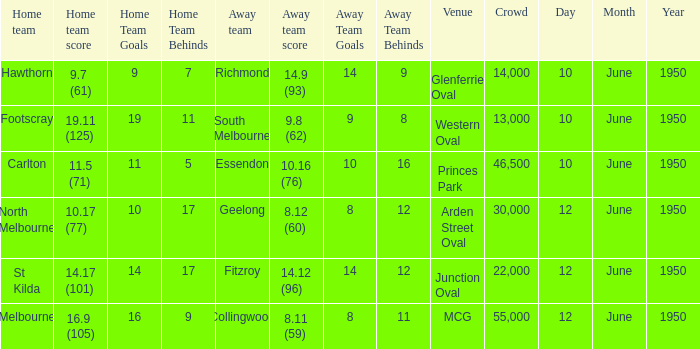What was the crowd when the VFL played MCG? 55000.0. 